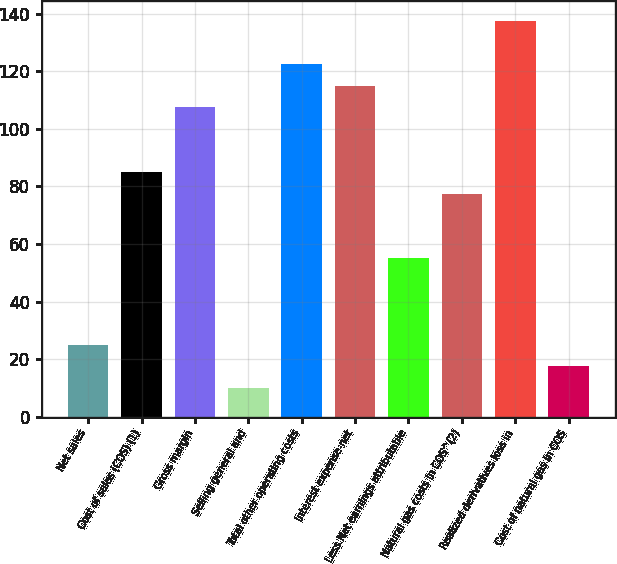<chart> <loc_0><loc_0><loc_500><loc_500><bar_chart><fcel>Net sales<fcel>Cost of sales (COS) (1)<fcel>Gross margin<fcel>Selling general and<fcel>Total other operating costs<fcel>Interest expense-net<fcel>Less Net earnings attributable<fcel>Natural gas costs in COS^(2)<fcel>Realized derivatives loss in<fcel>Cost of natural gas in COS<nl><fcel>25<fcel>85<fcel>107.5<fcel>10<fcel>122.5<fcel>115<fcel>55<fcel>77.5<fcel>137.5<fcel>17.5<nl></chart> 